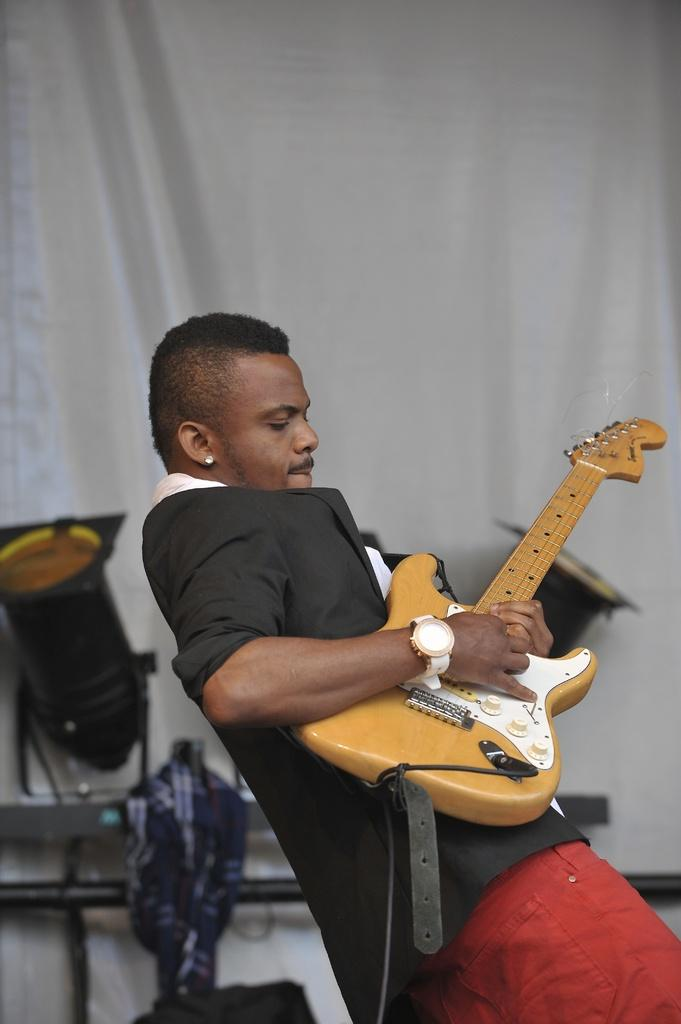What is the person in the image doing? The person is playing a guitar. What type of clothing is the person wearing on their lower body? The person is wearing red pants. What type of clothing is the person wearing on their upper body? The person is wearing a black coat. What can be seen in the background of the image? There is a curtain and a cloth piece in the background of the image. What type of lighting is present in the image? Focus lights are present in the image. How many eyes does the steel have in the image? There is no steel or eyes present in the image. What type of fiction is being performed by the person in the image? The image does not depict any fictional performance; the person is playing a guitar, which is a real-life activity. 